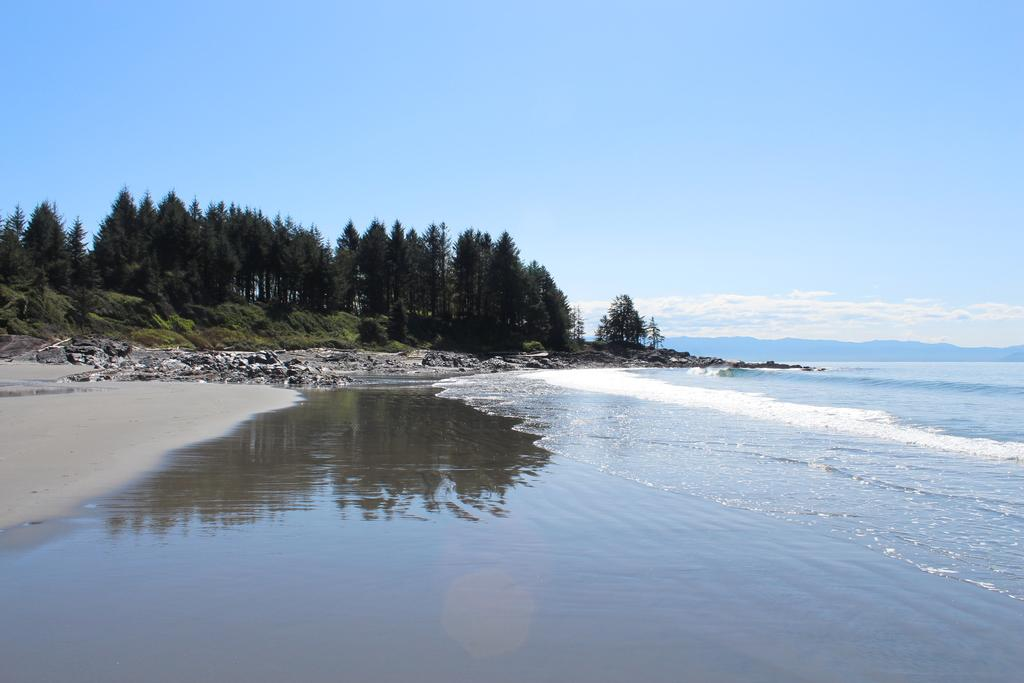What is located in the center of the image? There are trees, hills, rocks, and grass in the center of the image. What is present at the bottom of the image? There is water and soil at the bottom of the image. What can be seen in the sky at the top of the image? Clouds are present in the sky at the top of the image. What year is depicted in the image? The image does not depict a specific year; it is a landscape scene without any time-related elements. What activity is taking place in the image? There is no specific activity taking place in the image; it is a static landscape scene. 